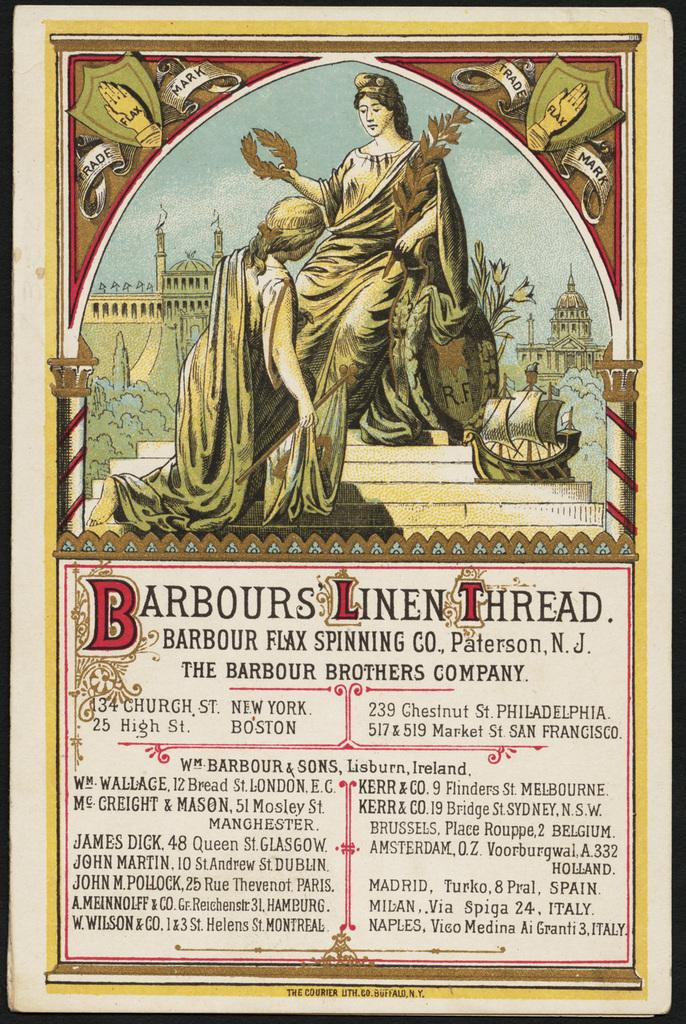<image>
Give a short and clear explanation of the subsequent image. An old looking image that has the name barbours linen thread on the center. 